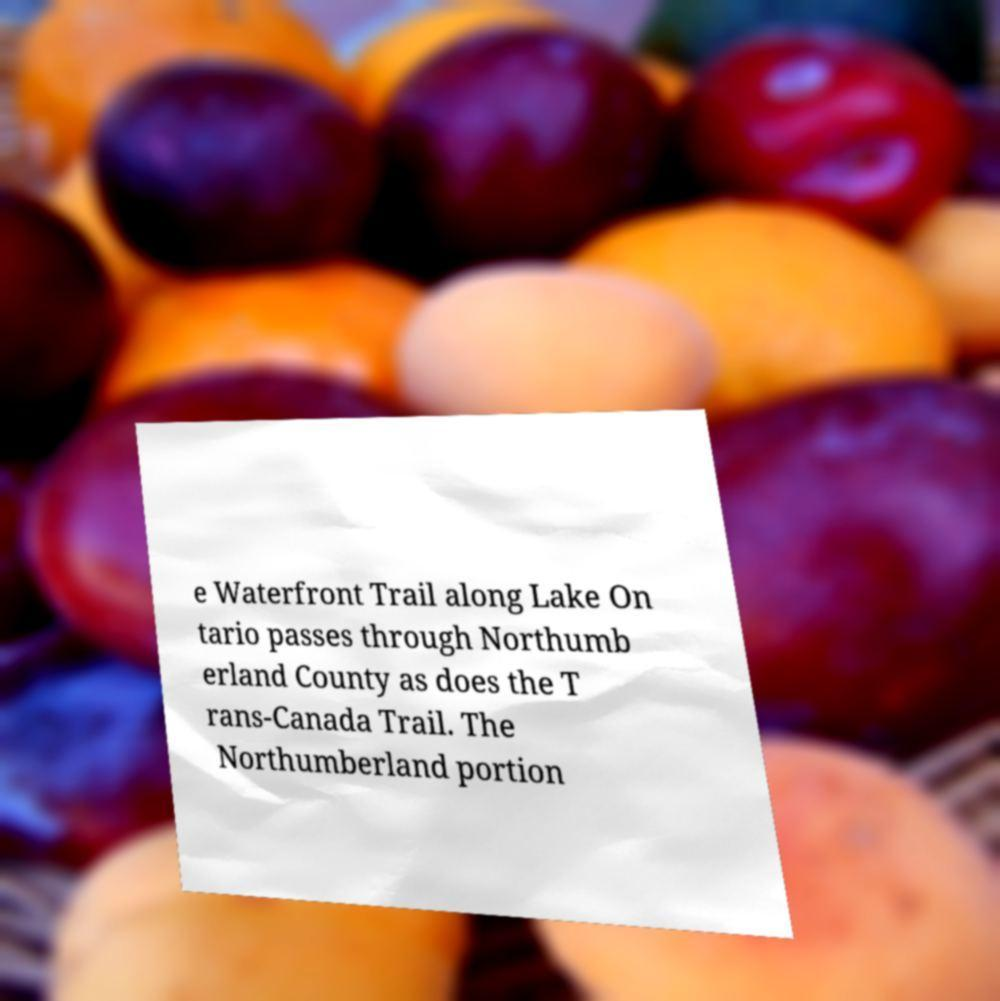Can you read and provide the text displayed in the image?This photo seems to have some interesting text. Can you extract and type it out for me? e Waterfront Trail along Lake On tario passes through Northumb erland County as does the T rans-Canada Trail. The Northumberland portion 